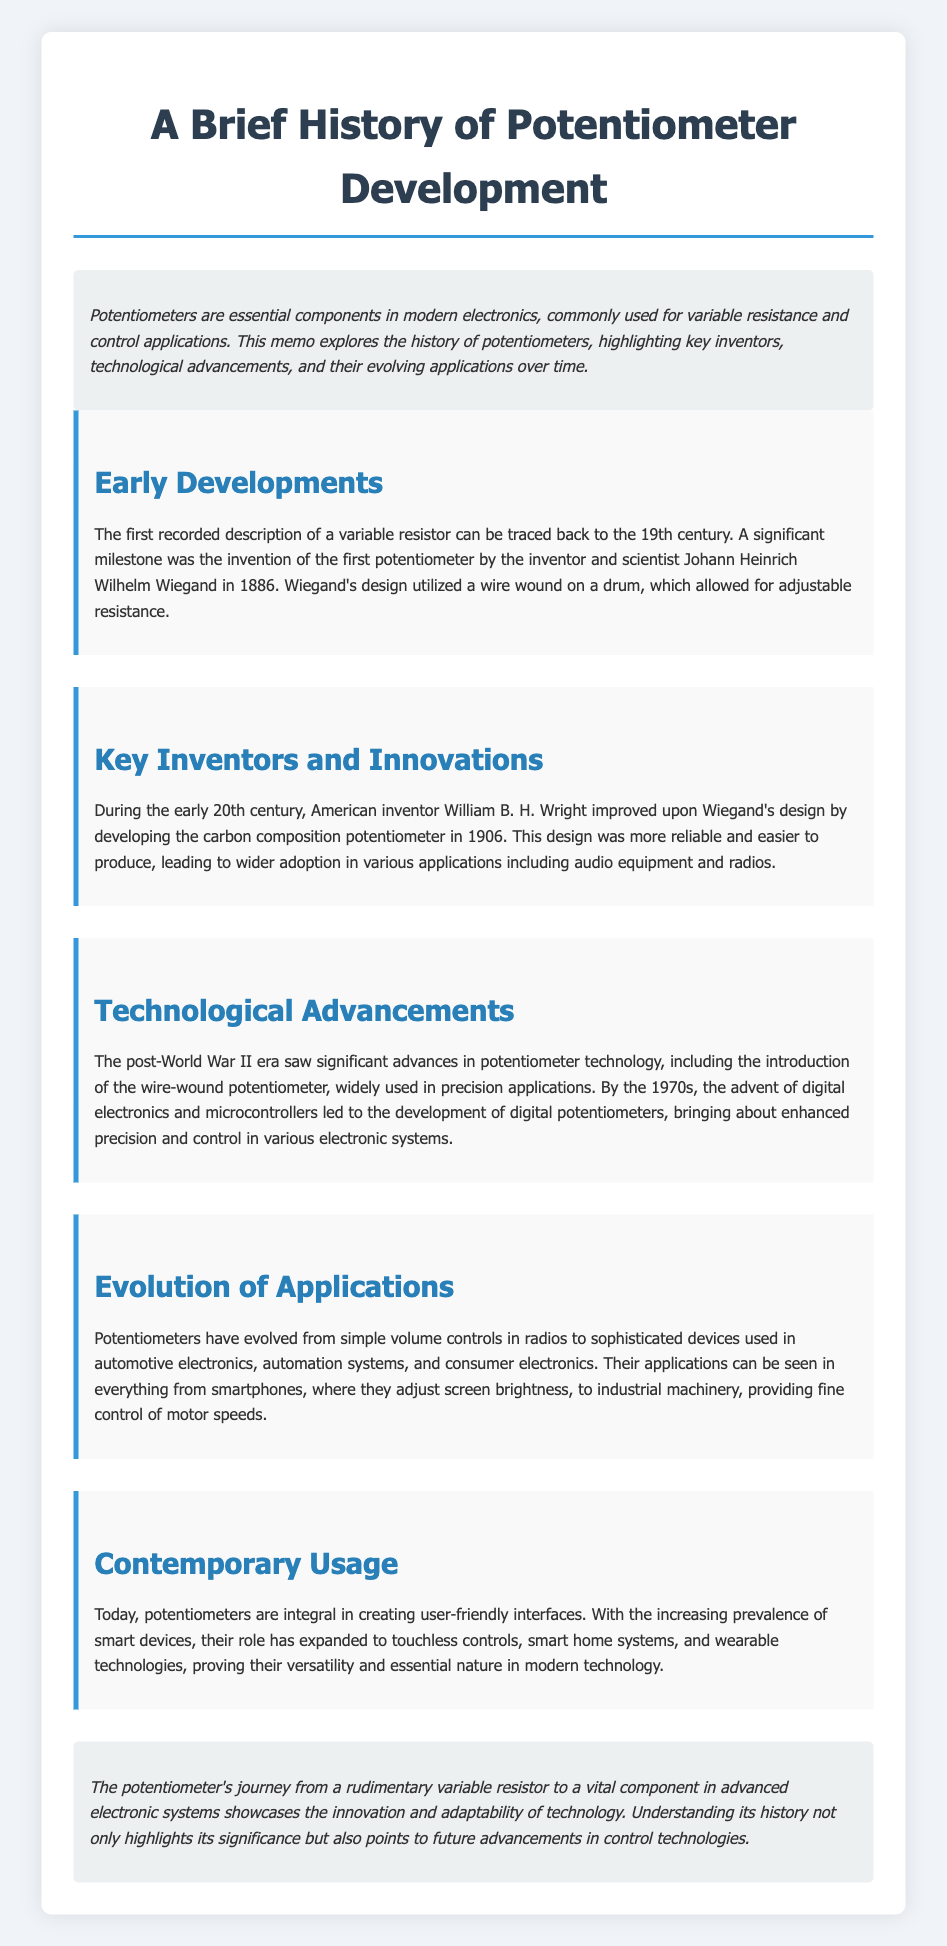What year was the first potentiometer invented? The memo states that Johann Heinrich Wilhelm Wiegand invented the first potentiometer in 1886.
Answer: 1886 Who improved Wiegand's design in 1906? The document names William B. H. Wright as the inventor who improved upon Wiegand's design by developing the carbon composition potentiometer.
Answer: William B. H. Wright What type of potentiometer became widely used after World War II? The document mentions the introduction of the wire-wound potentiometer as significant after World War II.
Answer: Wire-wound potentiometer In which decade did digital potentiometers emerge? The text indicates that the advent of digital electronics and microcontrollers led to the development of digital potentiometers by the 1970s.
Answer: 1970s What industries use potentiometers today? The document explains that potentiometers are used in automotive electronics, automation systems, and consumer electronics.
Answer: Automotive, automation, consumer electronics What was a primary application of potentiometers in the early 20th century? The memo highlights that carbon composition potentiometers were adopted in audio equipment and radios.
Answer: Audio equipment and radios What do potentiometers adjust in smartphones? The document states that they are used to adjust screen brightness in smartphones.
Answer: Screen brightness What does the conclusion summarize about the potentiometer's journey? The conclusion mentions that the journey showcases the innovation and adaptability of technology.
Answer: Innovation and adaptability 